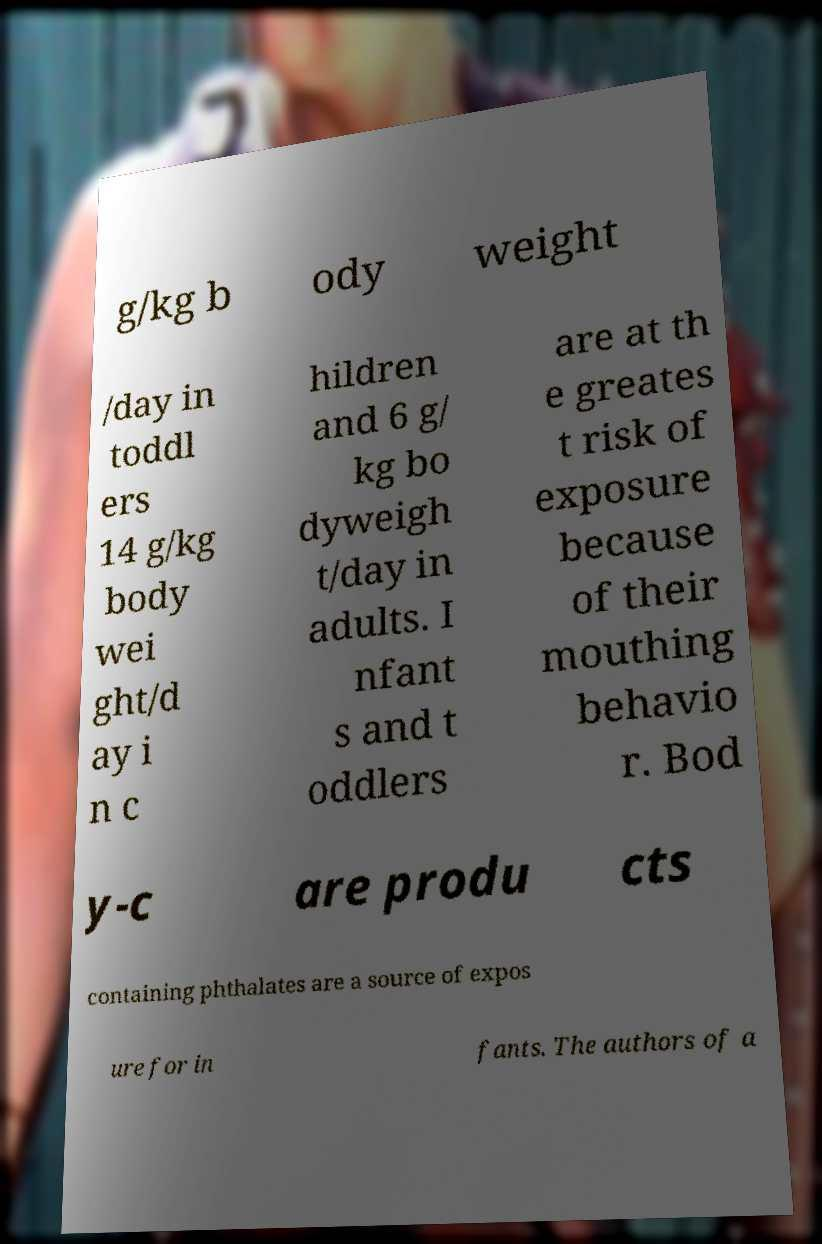For documentation purposes, I need the text within this image transcribed. Could you provide that? g/kg b ody weight /day in toddl ers 14 g/kg body wei ght/d ay i n c hildren and 6 g/ kg bo dyweigh t/day in adults. I nfant s and t oddlers are at th e greates t risk of exposure because of their mouthing behavio r. Bod y-c are produ cts containing phthalates are a source of expos ure for in fants. The authors of a 